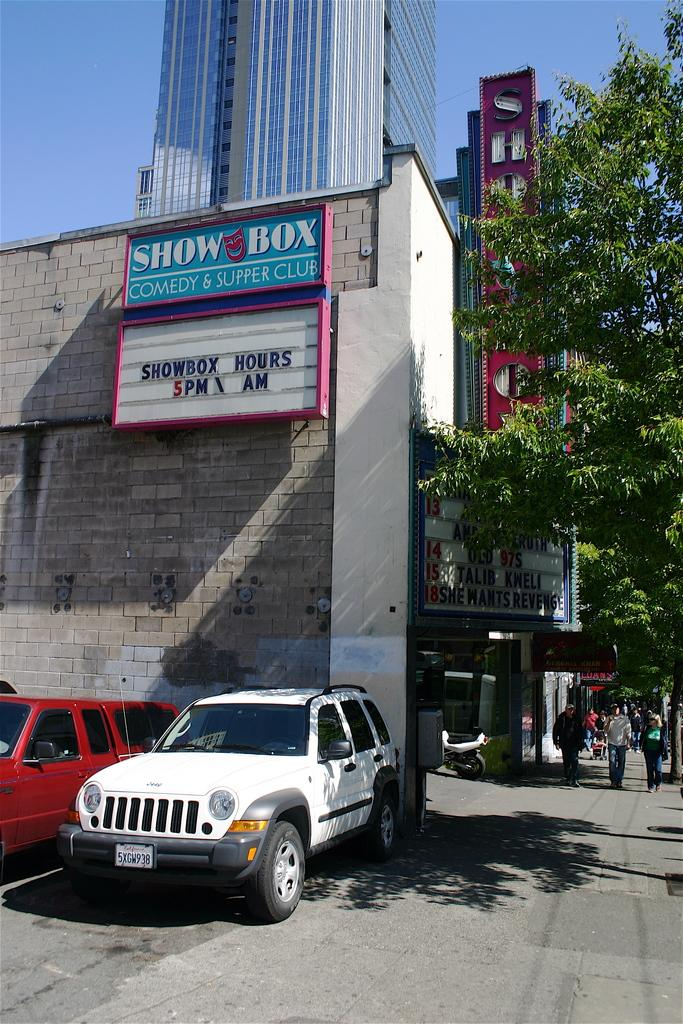<image>
Describe the image concisely. Building that houses the Show Box Comedy & Supper Club. 